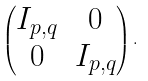<formula> <loc_0><loc_0><loc_500><loc_500>\begin{pmatrix} I _ { p , q } & 0 \\ 0 & I _ { p , q } \end{pmatrix} .</formula> 